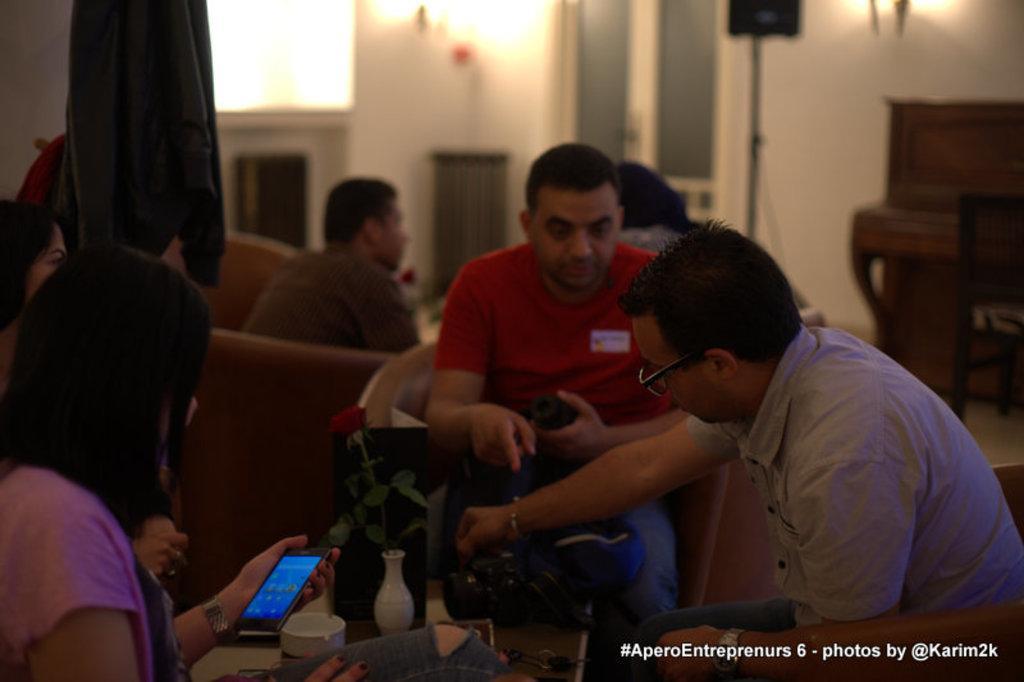How would you summarize this image in a sentence or two? In the image we can see there are people who are sitting on chair. 